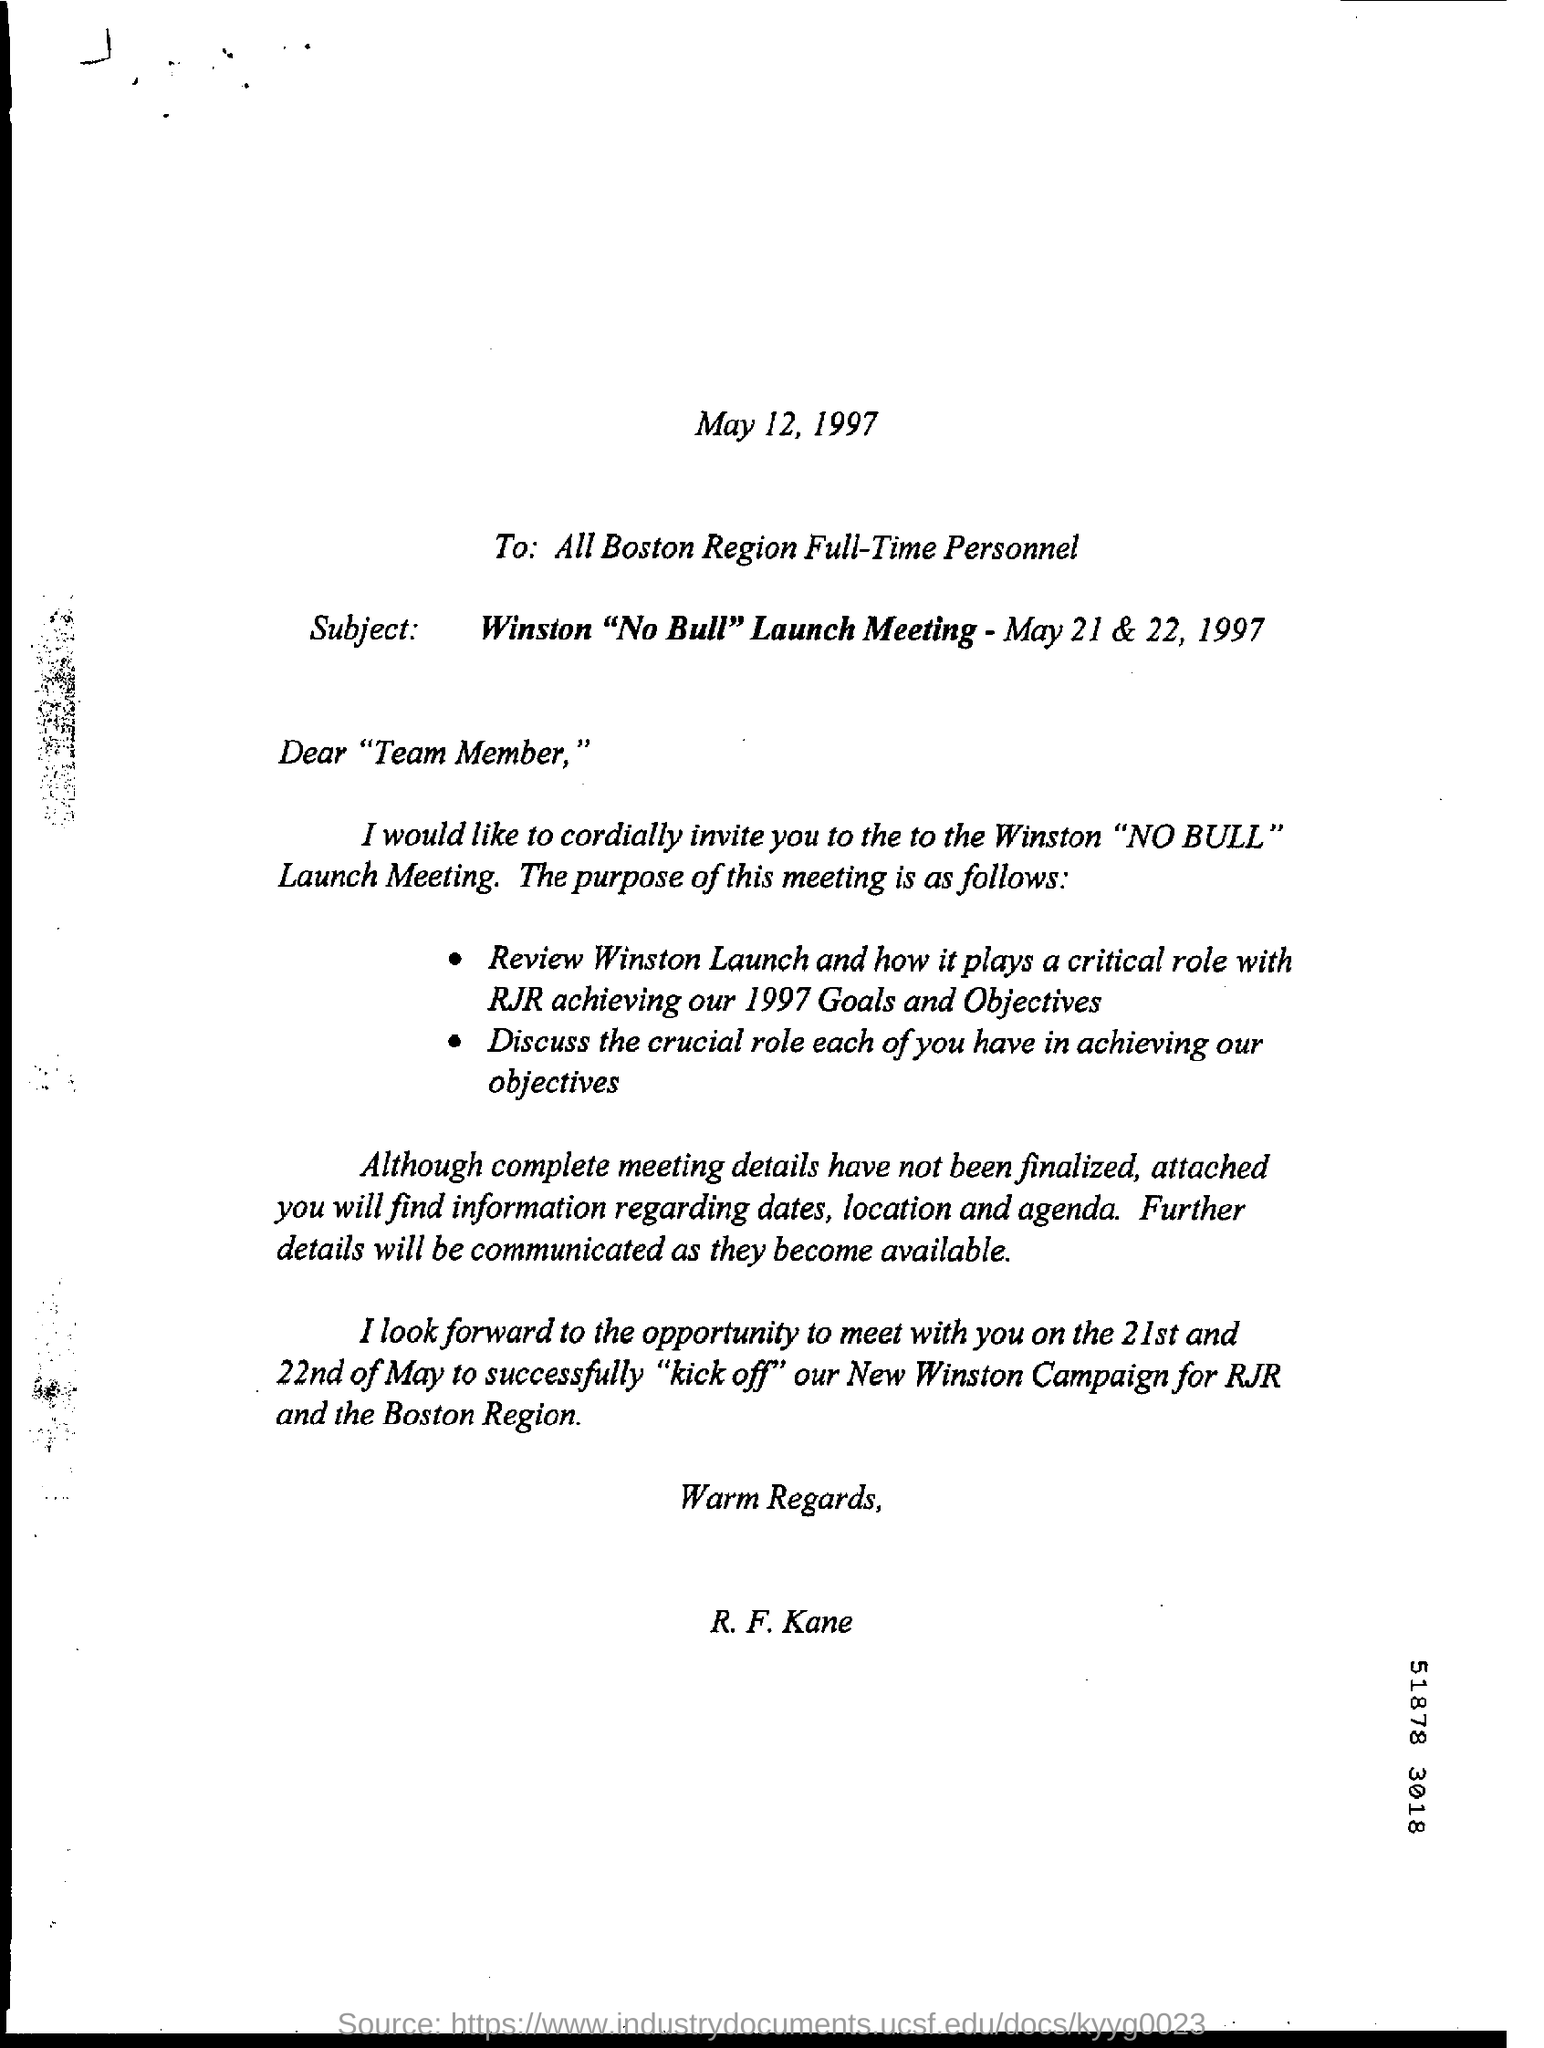What is the date mentioned in the top of the document ?
Provide a succinct answer. May 12, 1997. What is the Date mentioned in the Subject Line ?
Offer a very short reply. May 21 & 22, 1997. What is the Written in  To Field ?
Keep it short and to the point. All Boston Region Full-Time Personnel. 